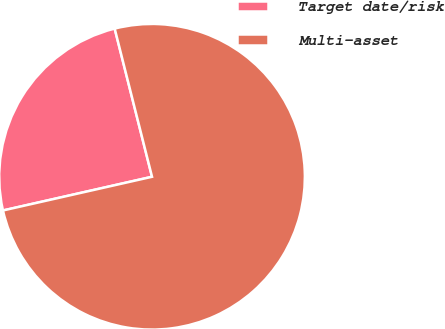<chart> <loc_0><loc_0><loc_500><loc_500><pie_chart><fcel>Target date/risk<fcel>Multi-asset<nl><fcel>24.61%<fcel>75.39%<nl></chart> 